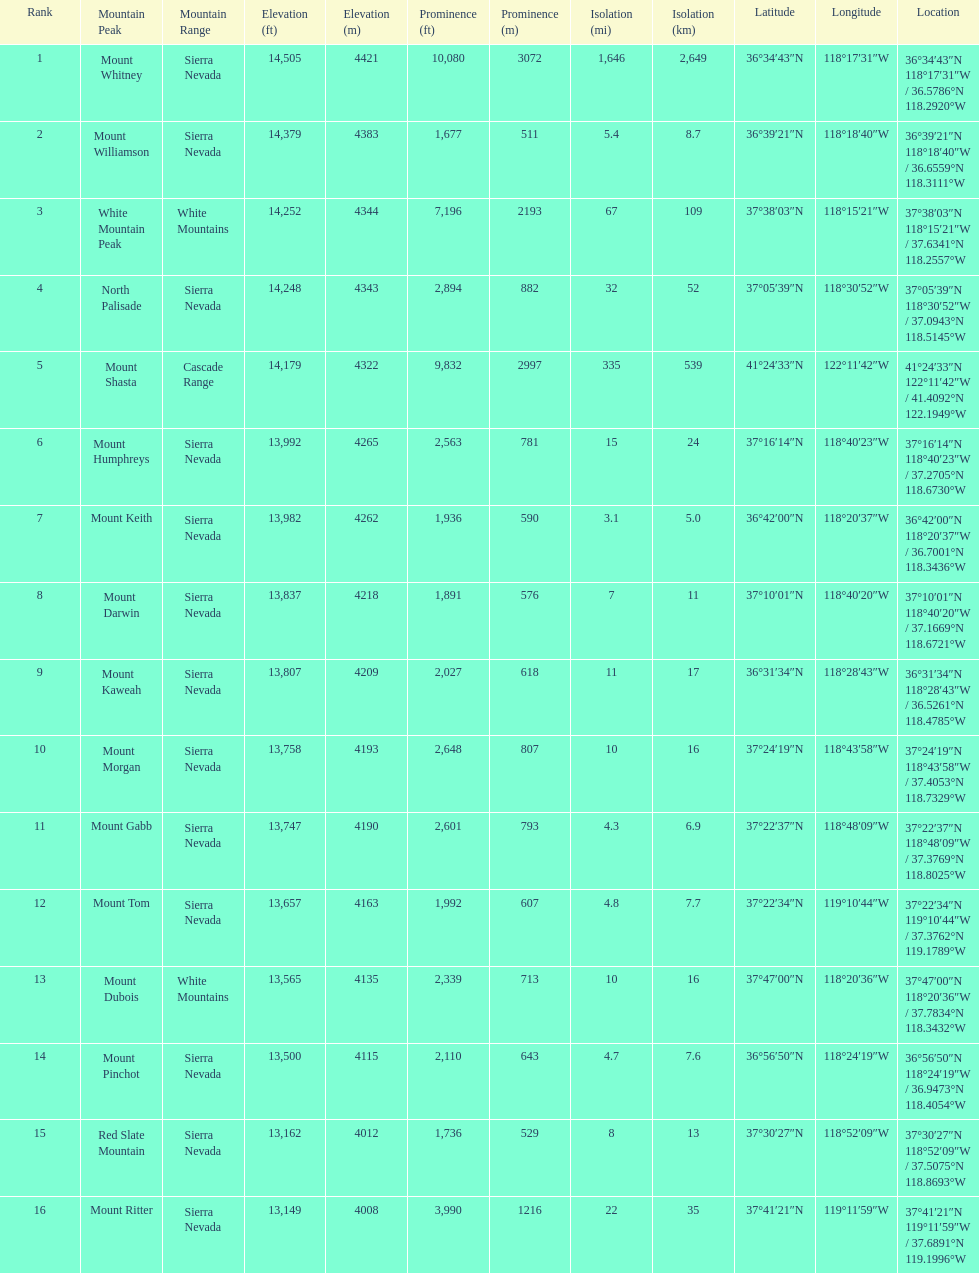Which mountain peak has the most isolation? Mount Whitney. 